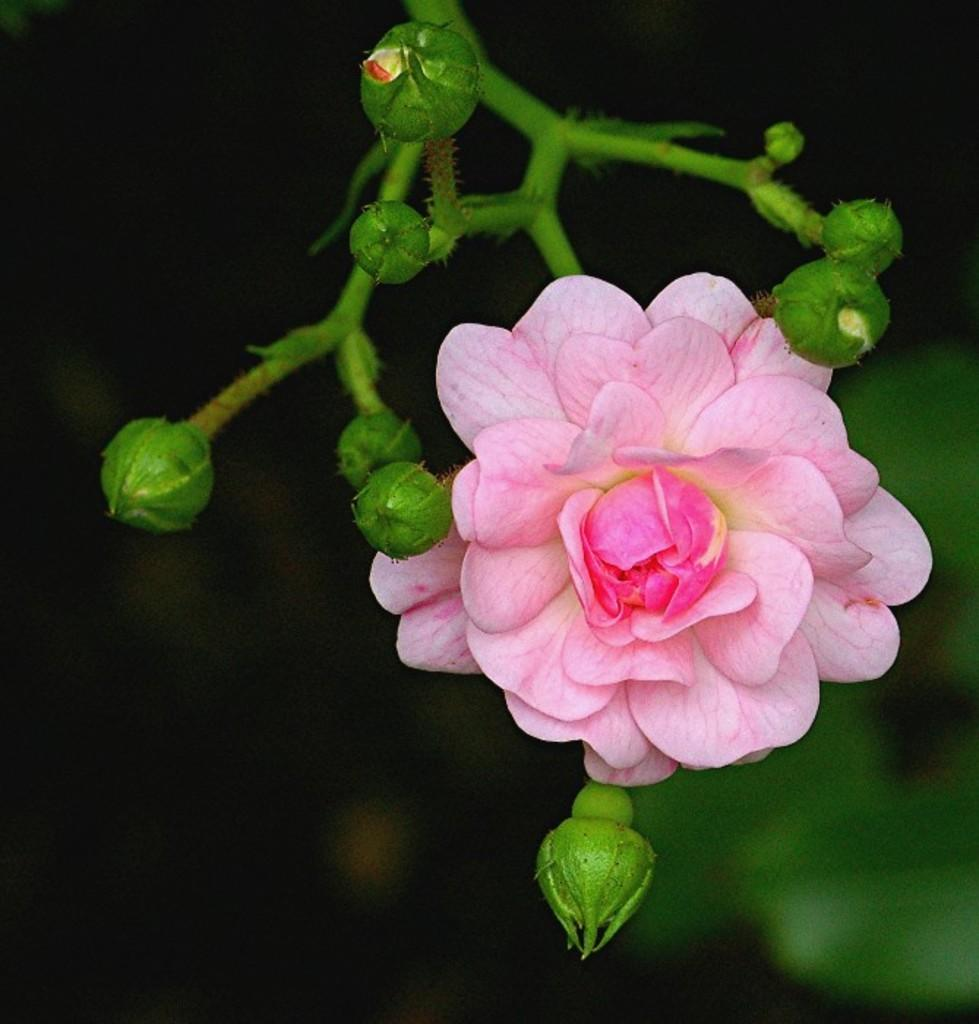What is the main subject of the image? The main subject of the image is a flower. Are there any other parts of the flower visible in the image? Yes, there are buds in the image. Can you describe the background of the flower? The background of the image is blurred. What is the edge of the flower like in the image? The edge of the flower cannot be determined from the image, as the focus is on the flower itself and the buds, not the edges. 